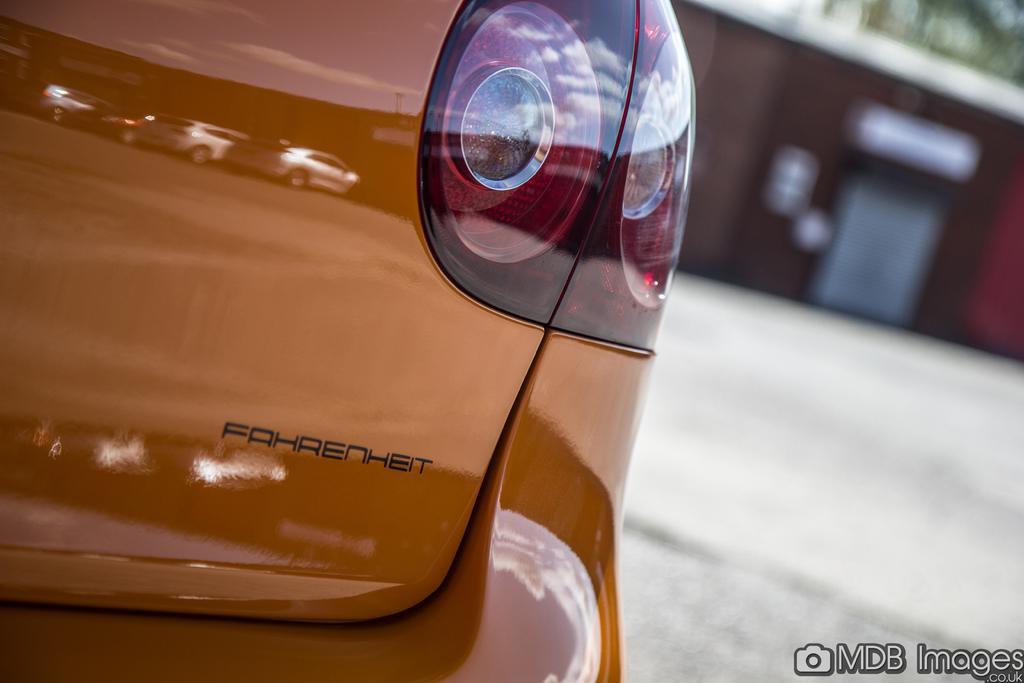How would you summarize this image in a sentence or two? In this picture there is a car which is in the center and the background is blurry. 